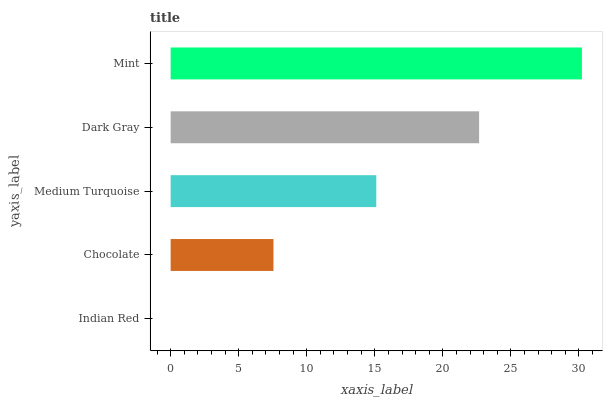Is Indian Red the minimum?
Answer yes or no. Yes. Is Mint the maximum?
Answer yes or no. Yes. Is Chocolate the minimum?
Answer yes or no. No. Is Chocolate the maximum?
Answer yes or no. No. Is Chocolate greater than Indian Red?
Answer yes or no. Yes. Is Indian Red less than Chocolate?
Answer yes or no. Yes. Is Indian Red greater than Chocolate?
Answer yes or no. No. Is Chocolate less than Indian Red?
Answer yes or no. No. Is Medium Turquoise the high median?
Answer yes or no. Yes. Is Medium Turquoise the low median?
Answer yes or no. Yes. Is Indian Red the high median?
Answer yes or no. No. Is Dark Gray the low median?
Answer yes or no. No. 